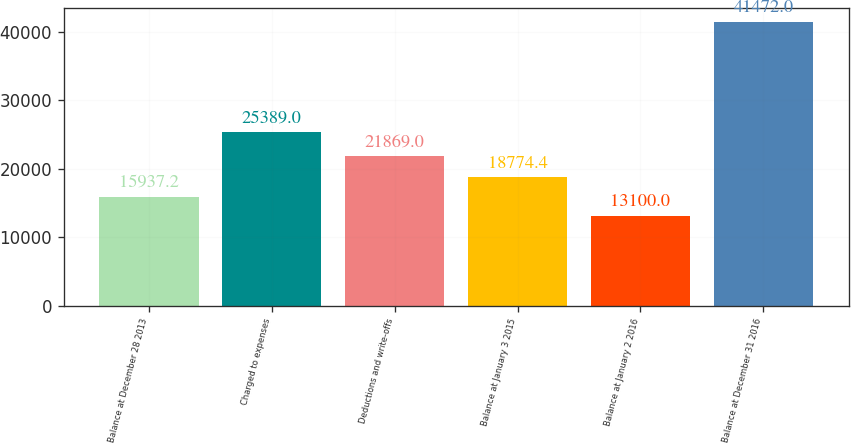<chart> <loc_0><loc_0><loc_500><loc_500><bar_chart><fcel>Balance at December 28 2013<fcel>Charged to expenses<fcel>Deductions and write-offs<fcel>Balance at January 3 2015<fcel>Balance at January 2 2016<fcel>Balance at December 31 2016<nl><fcel>15937.2<fcel>25389<fcel>21869<fcel>18774.4<fcel>13100<fcel>41472<nl></chart> 